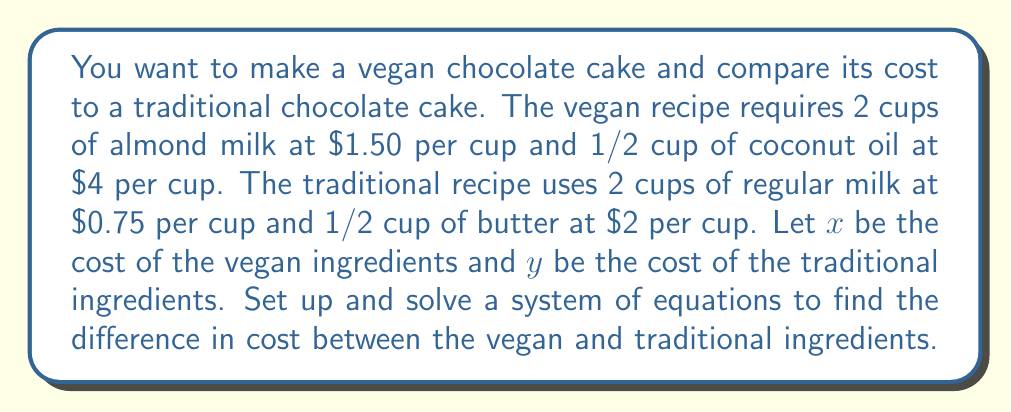Can you solve this math problem? Let's approach this step-by-step:

1) First, let's set up equations for each recipe:

   Vegan recipe: $x = 2(1.50) + \frac{1}{2}(4)$
   Traditional recipe: $y = 2(0.75) + \frac{1}{2}(2)$

2) Simplify each equation:

   $x = 3 + 2 = 5$
   $y = 1.5 + 1 = 2.5$

3) Now we have a system of equations:

   $$\begin{cases}
   x = 5 \\
   y = 2.5
   \end{cases}$$

4) To find the difference in cost, we subtract $y$ from $x$:

   Difference = $x - y = 5 - 2.5 = 2.5$

Therefore, the vegan ingredients cost $2.50 more than the traditional ingredients.
Answer: $2.50 